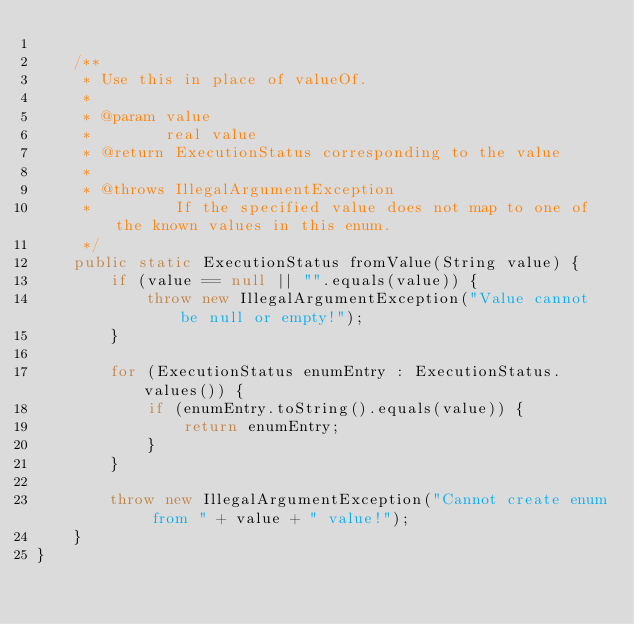Convert code to text. <code><loc_0><loc_0><loc_500><loc_500><_Java_>
    /**
     * Use this in place of valueOf.
     *
     * @param value
     *        real value
     * @return ExecutionStatus corresponding to the value
     *
     * @throws IllegalArgumentException
     *         If the specified value does not map to one of the known values in this enum.
     */
    public static ExecutionStatus fromValue(String value) {
        if (value == null || "".equals(value)) {
            throw new IllegalArgumentException("Value cannot be null or empty!");
        }

        for (ExecutionStatus enumEntry : ExecutionStatus.values()) {
            if (enumEntry.toString().equals(value)) {
                return enumEntry;
            }
        }

        throw new IllegalArgumentException("Cannot create enum from " + value + " value!");
    }
}
</code> 